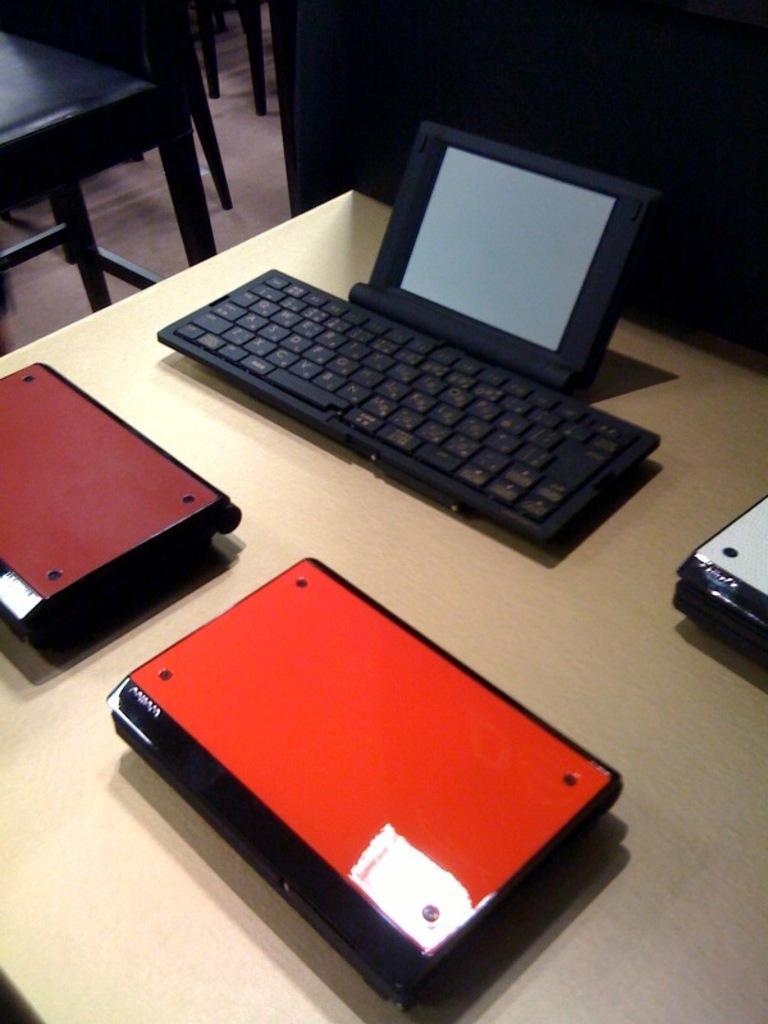Describe this image in one or two sentences. In this image I can see the keyboard, screen and there are maroon, red, white and black color objects on the cream color surface. To the side I can see the chairs. 